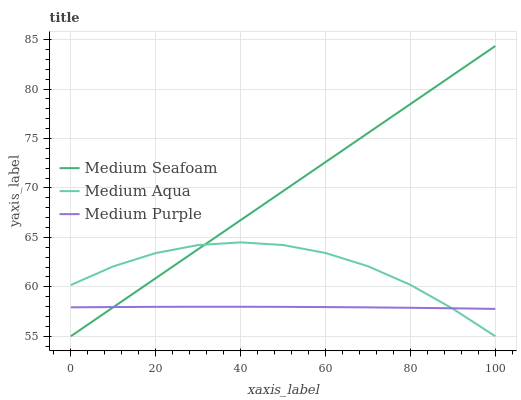Does Medium Purple have the minimum area under the curve?
Answer yes or no. Yes. Does Medium Seafoam have the maximum area under the curve?
Answer yes or no. Yes. Does Medium Aqua have the minimum area under the curve?
Answer yes or no. No. Does Medium Aqua have the maximum area under the curve?
Answer yes or no. No. Is Medium Seafoam the smoothest?
Answer yes or no. Yes. Is Medium Aqua the roughest?
Answer yes or no. Yes. Is Medium Aqua the smoothest?
Answer yes or no. No. Is Medium Seafoam the roughest?
Answer yes or no. No. Does Medium Aqua have the highest value?
Answer yes or no. No. 